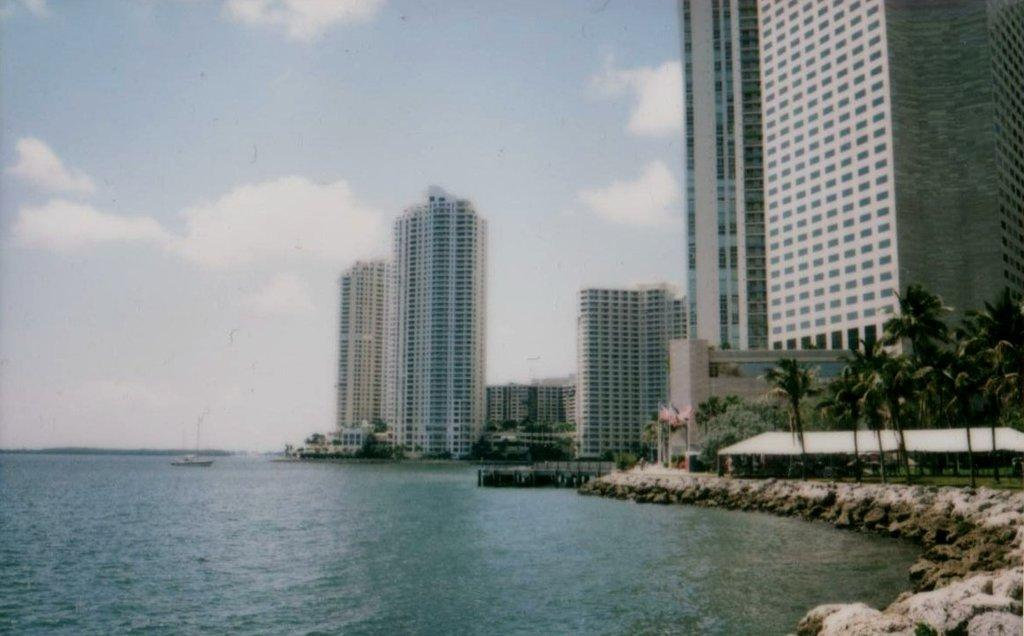What type of structures can be seen in the image? There are buildings in the image. What natural elements are present in the image? There are trees, plants, and stones visible in the image. What type of dwelling is present in the image? There is a hut in the image. What mode of transportation can be seen in the image? There is a boat sailing on the water in the image. What part of the natural environment is visible in the background of the image? The sky is visible in the background of the image. How does the beginner learn to use the pail in the image? There is no pail present in the image, so it is not possible to answer that question. 